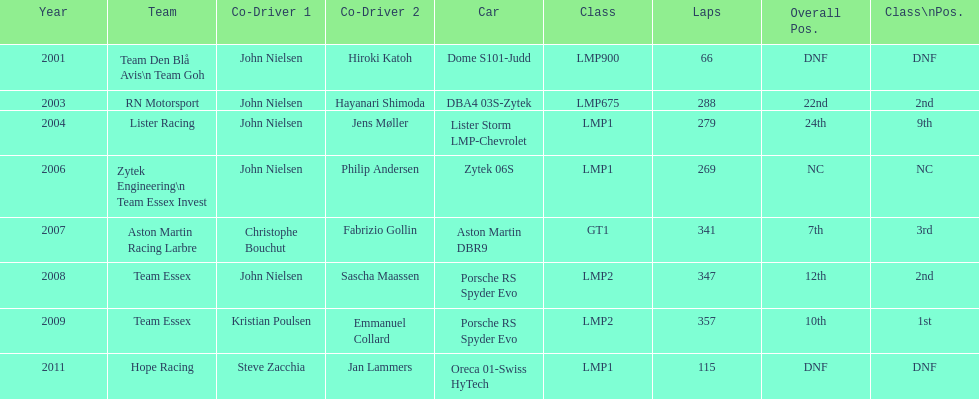Who was casper elgaard's co-driver the most often for the 24 hours of le mans? John Nielsen. 